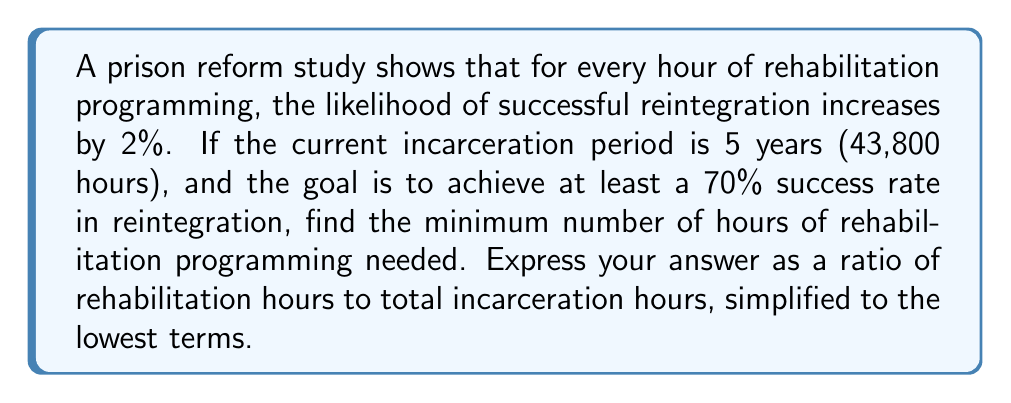Show me your answer to this math problem. 1) Let $x$ be the number of rehabilitation hours needed.

2) Each hour increases success by 2%, so $x$ hours increase success by $2x\%$.

3) We need this to be at least 70%:

   $$2x \geq 70$$

4) Solving for $x$:

   $$x \geq 35$$

5) So we need at least 35 hours of rehabilitation programming.

6) The ratio of rehabilitation hours to total incarceration hours is:

   $$\frac{35}{43800}$$

7) Simplify this fraction:

   $$\frac{35}{43800} = \frac{1}{1251.4285...}$$

8) Since we can't have a fractional hour, we round up to the next whole number:

   $$\frac{1}{1251}$$

This is the simplified ratio in lowest terms.
Answer: $\frac{1}{1251}$ 